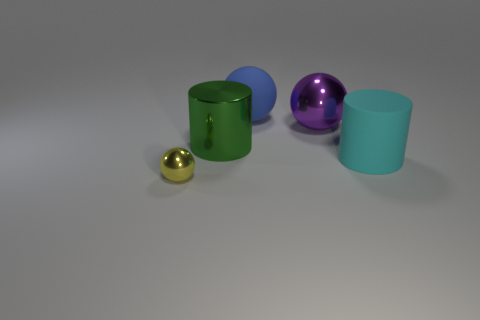Add 2 large blue matte balls. How many objects exist? 7 Subtract all cylinders. How many objects are left? 3 Subtract all big blue spheres. Subtract all tiny red metal balls. How many objects are left? 4 Add 2 purple shiny balls. How many purple shiny balls are left? 3 Add 5 tiny spheres. How many tiny spheres exist? 6 Subtract 1 blue balls. How many objects are left? 4 